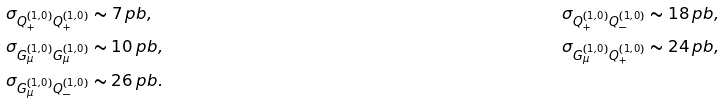<formula> <loc_0><loc_0><loc_500><loc_500>& \sigma _ { Q _ { + } ^ { ( 1 , 0 ) } Q _ { + } ^ { ( 1 , 0 ) } } \sim 7 \, p b , & & \sigma _ { Q _ { + } ^ { ( 1 , 0 ) } Q _ { - } ^ { ( 1 , 0 ) } } \sim 1 8 \, p b , \\ & \sigma _ { G _ { \mu } ^ { ( 1 , 0 ) } G _ { \mu } ^ { ( 1 , 0 ) } } \sim 1 0 \, p b , & & \sigma _ { G _ { \mu } ^ { ( 1 , 0 ) } Q _ { + } ^ { ( 1 , 0 ) } } \sim 2 4 \, p b , \\ & \sigma _ { G _ { \mu } ^ { ( 1 , 0 ) } Q _ { - } ^ { ( 1 , 0 ) } } \sim 2 6 \, p b .</formula> 